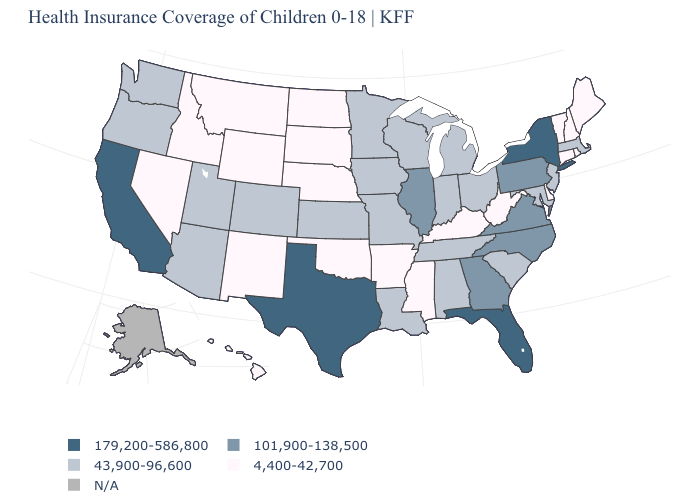Name the states that have a value in the range 4,400-42,700?
Keep it brief. Arkansas, Connecticut, Delaware, Hawaii, Idaho, Kentucky, Maine, Mississippi, Montana, Nebraska, Nevada, New Hampshire, New Mexico, North Dakota, Oklahoma, Rhode Island, South Dakota, Vermont, West Virginia, Wyoming. Name the states that have a value in the range 43,900-96,600?
Keep it brief. Alabama, Arizona, Colorado, Indiana, Iowa, Kansas, Louisiana, Maryland, Massachusetts, Michigan, Minnesota, Missouri, New Jersey, Ohio, Oregon, South Carolina, Tennessee, Utah, Washington, Wisconsin. Which states hav the highest value in the Northeast?
Write a very short answer. New York. What is the lowest value in the USA?
Answer briefly. 4,400-42,700. What is the lowest value in the South?
Concise answer only. 4,400-42,700. Name the states that have a value in the range 4,400-42,700?
Keep it brief. Arkansas, Connecticut, Delaware, Hawaii, Idaho, Kentucky, Maine, Mississippi, Montana, Nebraska, Nevada, New Hampshire, New Mexico, North Dakota, Oklahoma, Rhode Island, South Dakota, Vermont, West Virginia, Wyoming. Name the states that have a value in the range 101,900-138,500?
Answer briefly. Georgia, Illinois, North Carolina, Pennsylvania, Virginia. Is the legend a continuous bar?
Keep it brief. No. Does the map have missing data?
Write a very short answer. Yes. Name the states that have a value in the range 43,900-96,600?
Answer briefly. Alabama, Arizona, Colorado, Indiana, Iowa, Kansas, Louisiana, Maryland, Massachusetts, Michigan, Minnesota, Missouri, New Jersey, Ohio, Oregon, South Carolina, Tennessee, Utah, Washington, Wisconsin. Name the states that have a value in the range 43,900-96,600?
Concise answer only. Alabama, Arizona, Colorado, Indiana, Iowa, Kansas, Louisiana, Maryland, Massachusetts, Michigan, Minnesota, Missouri, New Jersey, Ohio, Oregon, South Carolina, Tennessee, Utah, Washington, Wisconsin. What is the lowest value in the USA?
Answer briefly. 4,400-42,700. Which states have the lowest value in the Northeast?
Answer briefly. Connecticut, Maine, New Hampshire, Rhode Island, Vermont. 